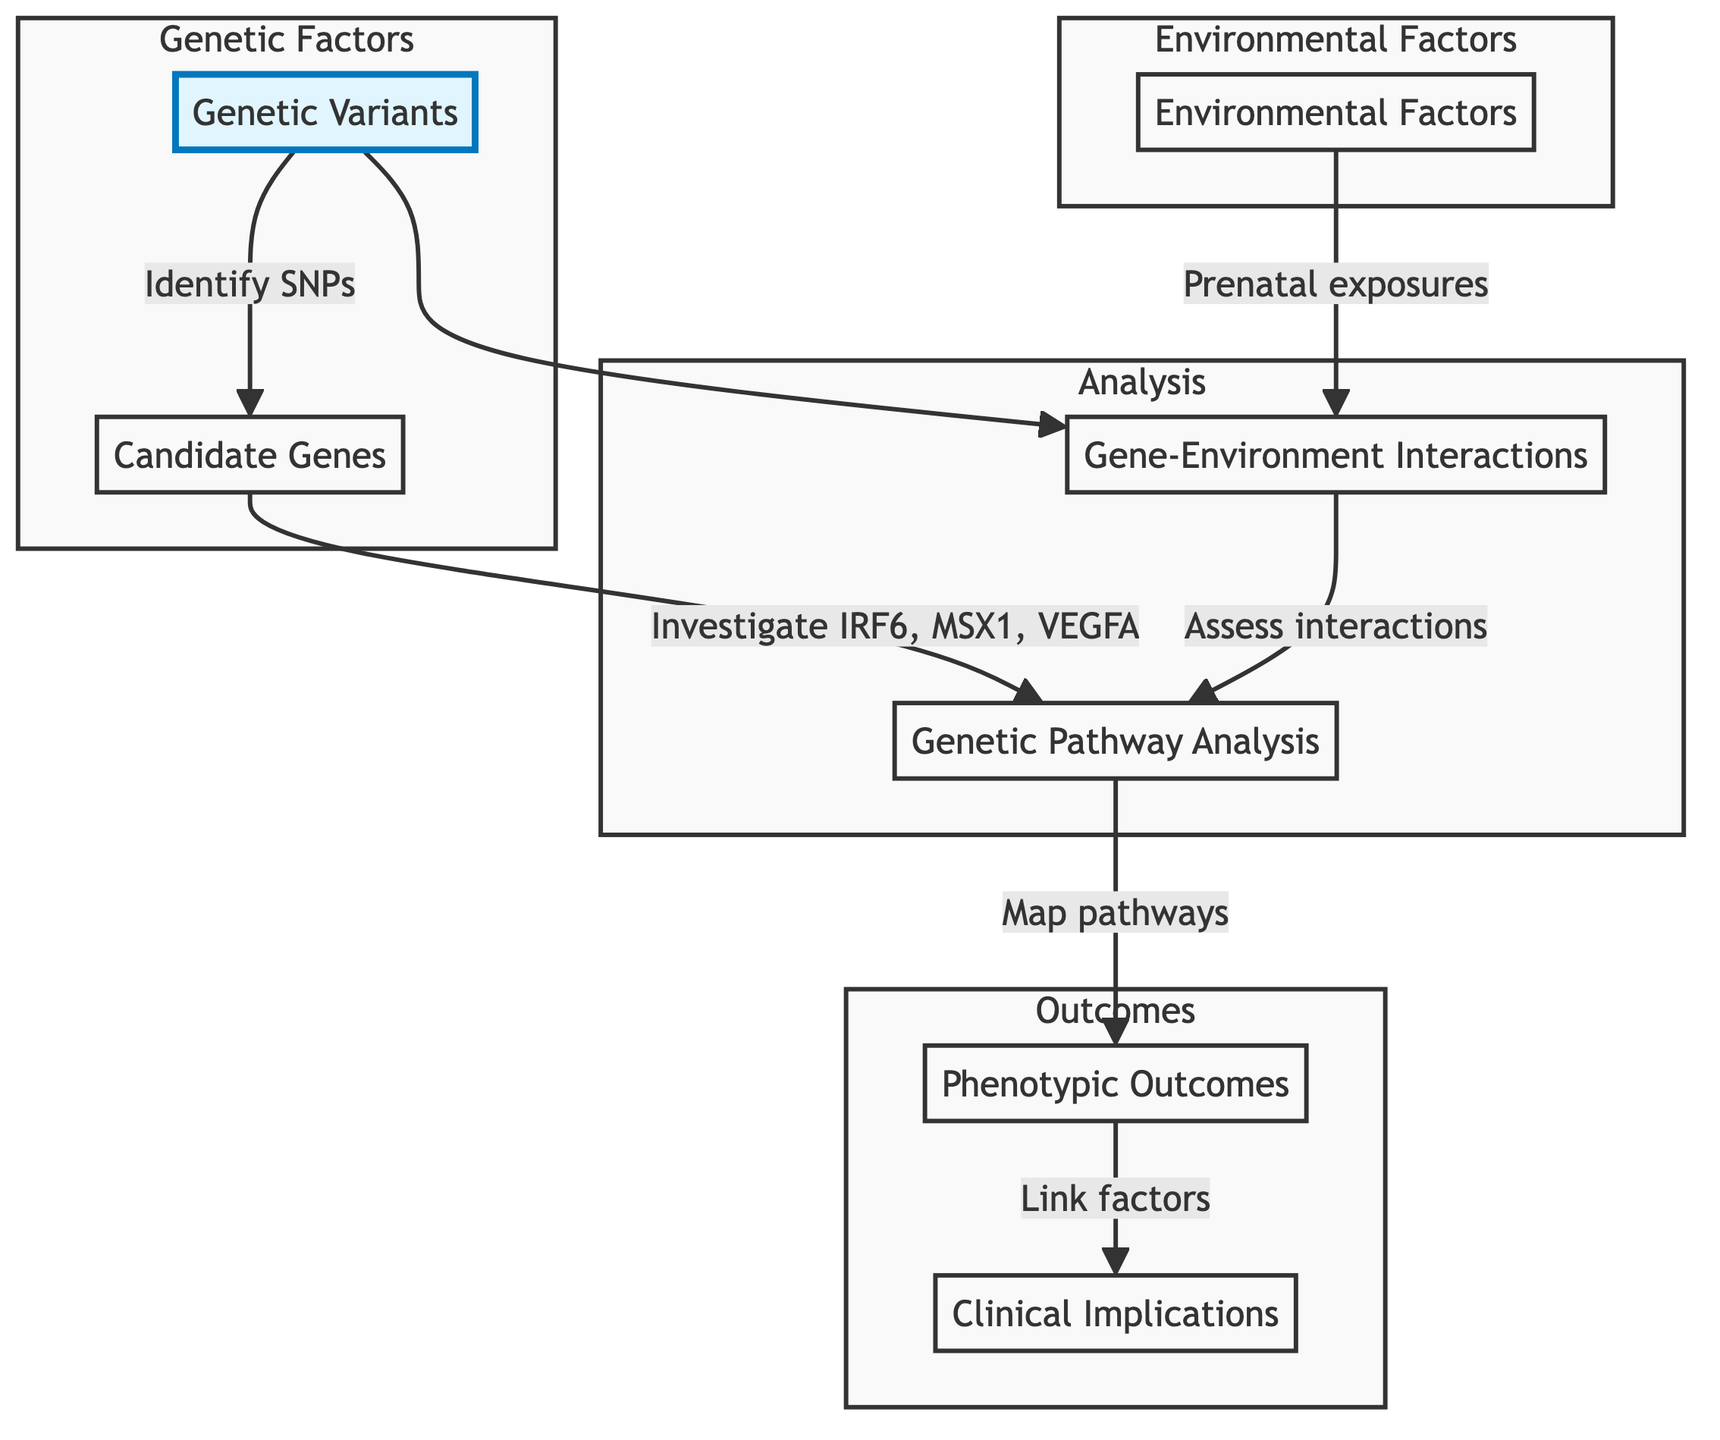What are the specific genetic variations indicated in the diagram? The diagram identifies “Genetic Variants” as a node, which is linked to examining specific SNPs related to cleft lip and palate.
Answer: Genetic Variants Which genes are regarded as candidate genes in this mapping? The diagram features a node labeled “Candidate Genes,” which investigates genes such as IRF6, MSX1, and VEGFA, indicating their role in craniofacial development.
Answer: IRF6, MSX1, VEGFA How many nodes are included in the flow chart? Counting the nodes in the diagram, there are a total of seven distinct elements: Genetic Variants, Candidate Genes, Environmental Factors, Gene-Environment Interactions, Genetic Pathway Analysis, Phenotypic Outcomes, and Clinical Implications.
Answer: Seven What interaction is examined between genetic predispositions and another factor? The diagram highlights “Gene-Environment Interactions,” which assesses how genetic predispositions may be influenced by environmental factors such as prenatal exposures.
Answer: Gene-Environment Interactions What do the phenotypic outcomes link to? According to the diagram, the node "Phenotypic Outcomes" links genetic and environmental factors to clinical presentations of cleft lip and palate, indicating a direct connection.
Answer: Clinical presentations of cleft lip and palate How is “Genetic Pathway Analysis” related to other factors? The “Genetic Pathway Analysis” node is reached from both “Candidate Genes” and “Gene-Environment Interactions,” suggesting its relevance in synthesizing information from these areas into understanding biological pathways.
Answer: Candidate Genes, Gene-Environment Interactions What is the final clinical focus of this mapping? The final node, "Clinical Implications," signifies the emphasis on how genetic insights can inform personalized surgical approaches and interventions for cleft lip and palate.
Answer: Personalized surgical approaches What type of relationships do the arrows in the diagram signify? The arrows in the diagram represent directional relationships that show the flow of information or influence between the nodes, indicating a systematic process of mapping genetic and environmental factors.
Answer: Directional relationships 